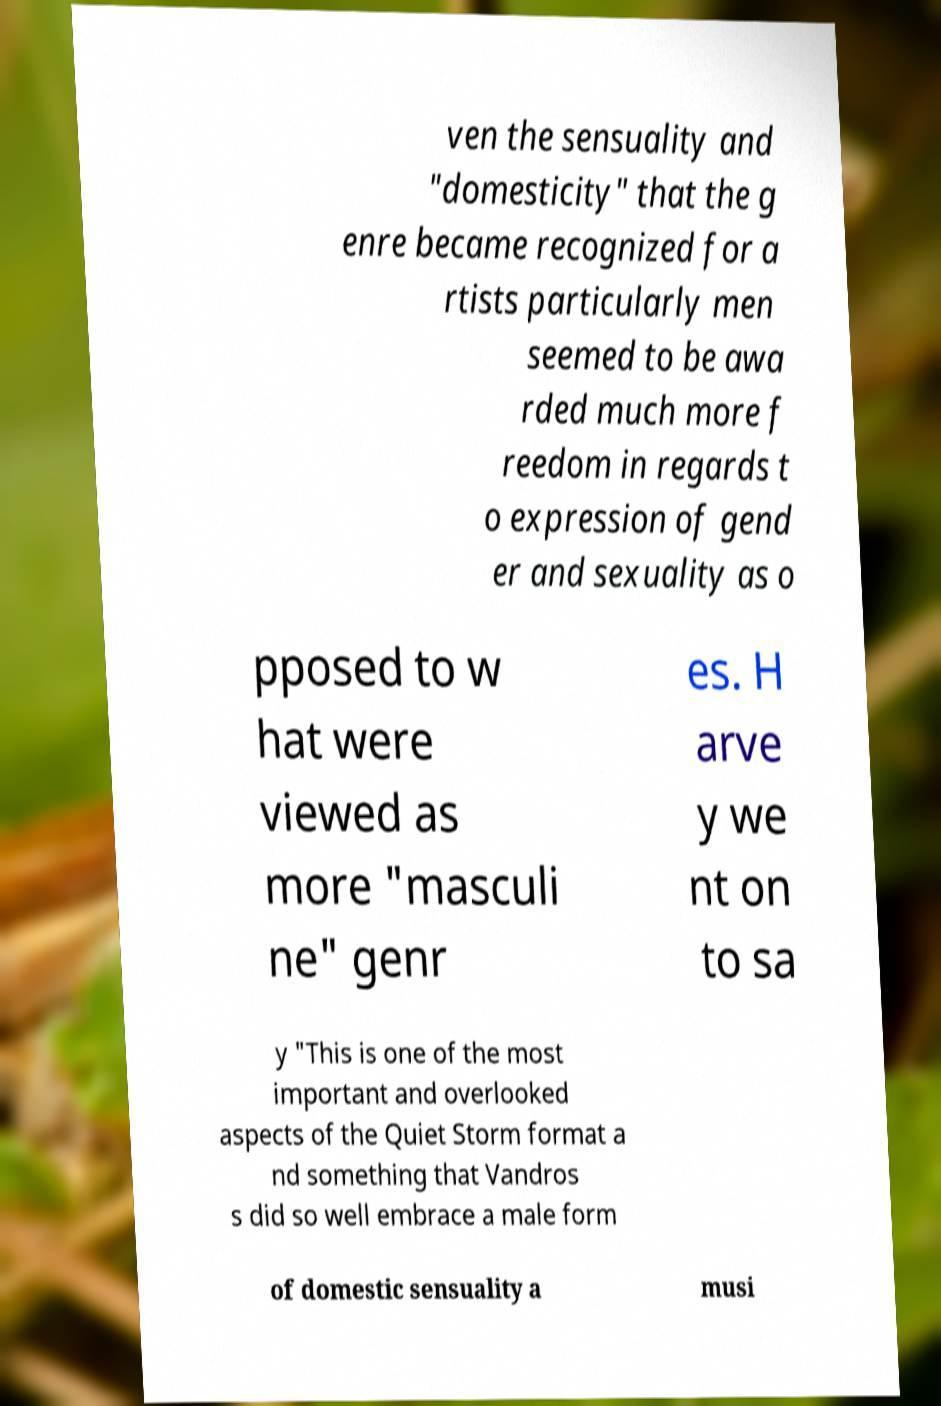For documentation purposes, I need the text within this image transcribed. Could you provide that? ven the sensuality and "domesticity" that the g enre became recognized for a rtists particularly men seemed to be awa rded much more f reedom in regards t o expression of gend er and sexuality as o pposed to w hat were viewed as more "masculi ne" genr es. H arve y we nt on to sa y "This is one of the most important and overlooked aspects of the Quiet Storm format a nd something that Vandros s did so well embrace a male form of domestic sensuality a musi 